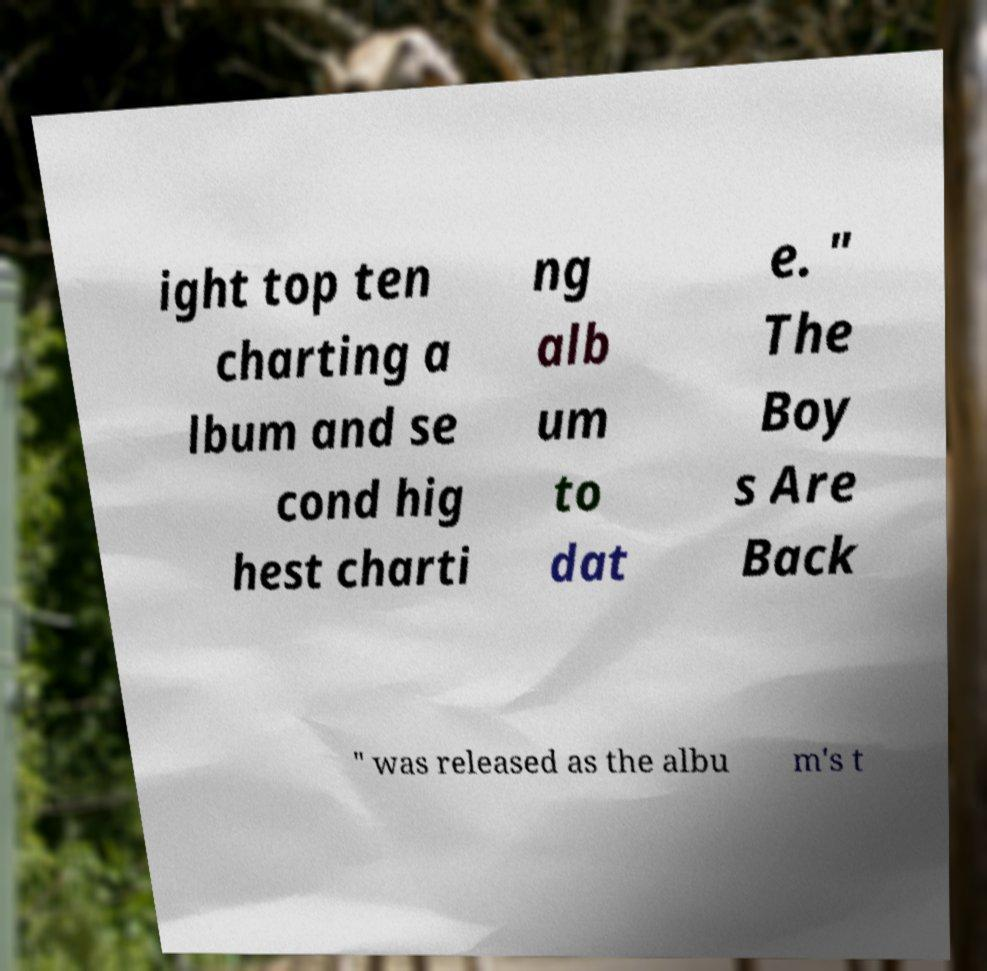Can you accurately transcribe the text from the provided image for me? ight top ten charting a lbum and se cond hig hest charti ng alb um to dat e. " The Boy s Are Back " was released as the albu m's t 